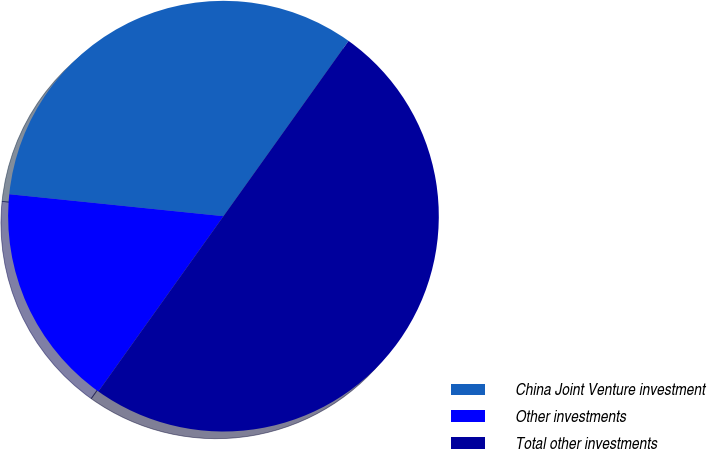<chart> <loc_0><loc_0><loc_500><loc_500><pie_chart><fcel>China Joint Venture investment<fcel>Other investments<fcel>Total other investments<nl><fcel>33.24%<fcel>16.76%<fcel>50.0%<nl></chart> 